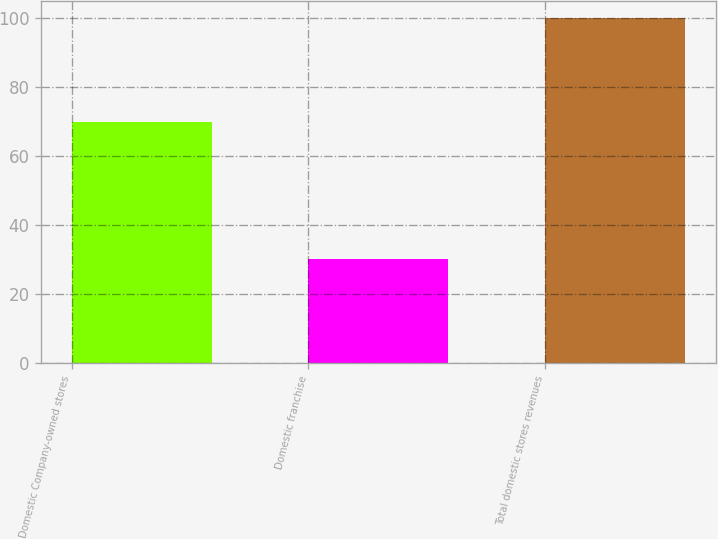<chart> <loc_0><loc_0><loc_500><loc_500><bar_chart><fcel>Domestic Company-owned stores<fcel>Domestic franchise<fcel>Total domestic stores revenues<nl><fcel>69.9<fcel>30.1<fcel>100<nl></chart> 